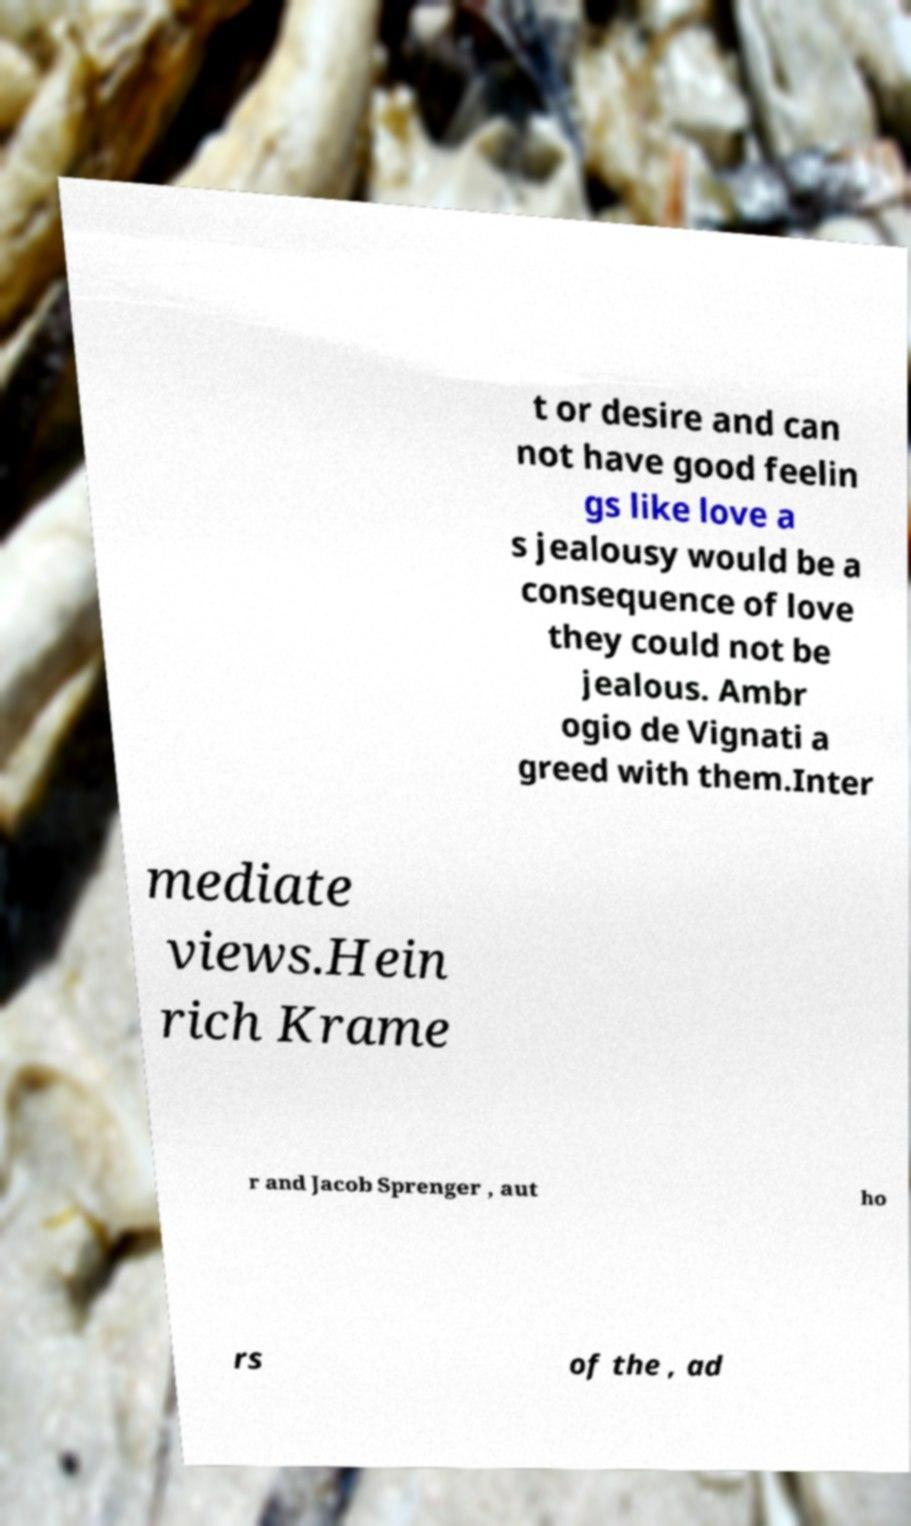There's text embedded in this image that I need extracted. Can you transcribe it verbatim? t or desire and can not have good feelin gs like love a s jealousy would be a consequence of love they could not be jealous. Ambr ogio de Vignati a greed with them.Inter mediate views.Hein rich Krame r and Jacob Sprenger , aut ho rs of the , ad 